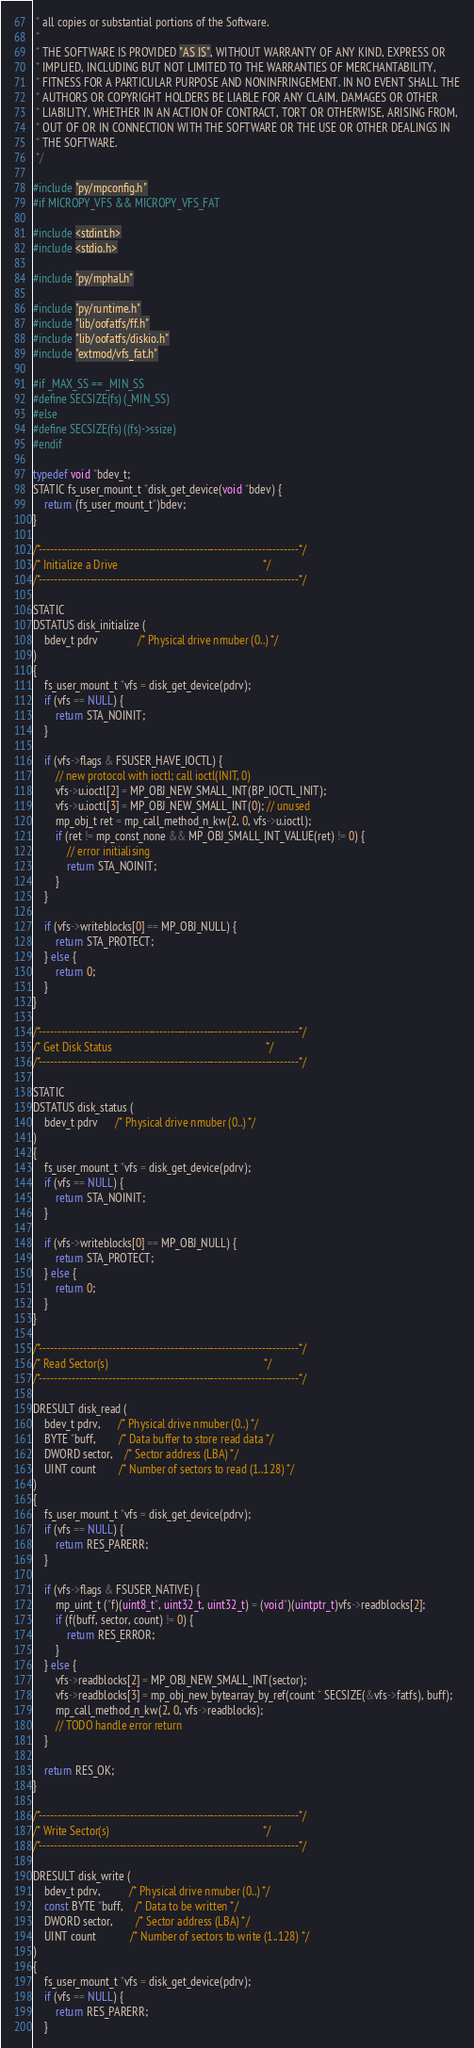Convert code to text. <code><loc_0><loc_0><loc_500><loc_500><_C_> * all copies or substantial portions of the Software.
 *
 * THE SOFTWARE IS PROVIDED "AS IS", WITHOUT WARRANTY OF ANY KIND, EXPRESS OR
 * IMPLIED, INCLUDING BUT NOT LIMITED TO THE WARRANTIES OF MERCHANTABILITY,
 * FITNESS FOR A PARTICULAR PURPOSE AND NONINFRINGEMENT. IN NO EVENT SHALL THE
 * AUTHORS OR COPYRIGHT HOLDERS BE LIABLE FOR ANY CLAIM, DAMAGES OR OTHER
 * LIABILITY, WHETHER IN AN ACTION OF CONTRACT, TORT OR OTHERWISE, ARISING FROM,
 * OUT OF OR IN CONNECTION WITH THE SOFTWARE OR THE USE OR OTHER DEALINGS IN
 * THE SOFTWARE.
 */

#include "py/mpconfig.h"
#if MICROPY_VFS && MICROPY_VFS_FAT

#include <stdint.h>
#include <stdio.h>

#include "py/mphal.h"

#include "py/runtime.h"
#include "lib/oofatfs/ff.h"
#include "lib/oofatfs/diskio.h"
#include "extmod/vfs_fat.h"

#if _MAX_SS == _MIN_SS
#define SECSIZE(fs) (_MIN_SS)
#else
#define SECSIZE(fs) ((fs)->ssize)
#endif

typedef void *bdev_t;
STATIC fs_user_mount_t *disk_get_device(void *bdev) {
    return (fs_user_mount_t*)bdev;
}

/*-----------------------------------------------------------------------*/
/* Initialize a Drive                                                    */
/*-----------------------------------------------------------------------*/

STATIC
DSTATUS disk_initialize (
    bdev_t pdrv              /* Physical drive nmuber (0..) */
)
{
    fs_user_mount_t *vfs = disk_get_device(pdrv);
    if (vfs == NULL) {
        return STA_NOINIT;
    }

    if (vfs->flags & FSUSER_HAVE_IOCTL) {
        // new protocol with ioctl; call ioctl(INIT, 0)
        vfs->u.ioctl[2] = MP_OBJ_NEW_SMALL_INT(BP_IOCTL_INIT);
        vfs->u.ioctl[3] = MP_OBJ_NEW_SMALL_INT(0); // unused
        mp_obj_t ret = mp_call_method_n_kw(2, 0, vfs->u.ioctl);
        if (ret != mp_const_none && MP_OBJ_SMALL_INT_VALUE(ret) != 0) {
            // error initialising
            return STA_NOINIT;
        }
    }

    if (vfs->writeblocks[0] == MP_OBJ_NULL) {
        return STA_PROTECT;
    } else {
        return 0;
    }
}

/*-----------------------------------------------------------------------*/
/* Get Disk Status                                                       */
/*-----------------------------------------------------------------------*/

STATIC
DSTATUS disk_status (
    bdev_t pdrv      /* Physical drive nmuber (0..) */
)
{
    fs_user_mount_t *vfs = disk_get_device(pdrv);
    if (vfs == NULL) {
        return STA_NOINIT;
    }

    if (vfs->writeblocks[0] == MP_OBJ_NULL) {
        return STA_PROTECT;
    } else {
        return 0;
    }
}

/*-----------------------------------------------------------------------*/
/* Read Sector(s)                                                        */
/*-----------------------------------------------------------------------*/

DRESULT disk_read (
    bdev_t pdrv,      /* Physical drive nmuber (0..) */
    BYTE *buff,        /* Data buffer to store read data */
    DWORD sector,    /* Sector address (LBA) */
    UINT count        /* Number of sectors to read (1..128) */
)
{
    fs_user_mount_t *vfs = disk_get_device(pdrv);
    if (vfs == NULL) {
        return RES_PARERR;
    }

    if (vfs->flags & FSUSER_NATIVE) {
        mp_uint_t (*f)(uint8_t*, uint32_t, uint32_t) = (void*)(uintptr_t)vfs->readblocks[2];
        if (f(buff, sector, count) != 0) {
            return RES_ERROR;
        }
    } else {
        vfs->readblocks[2] = MP_OBJ_NEW_SMALL_INT(sector);
        vfs->readblocks[3] = mp_obj_new_bytearray_by_ref(count * SECSIZE(&vfs->fatfs), buff);
        mp_call_method_n_kw(2, 0, vfs->readblocks);
        // TODO handle error return
    }

    return RES_OK;
}

/*-----------------------------------------------------------------------*/
/* Write Sector(s)                                                       */
/*-----------------------------------------------------------------------*/

DRESULT disk_write (
    bdev_t pdrv,          /* Physical drive nmuber (0..) */
    const BYTE *buff,    /* Data to be written */
    DWORD sector,        /* Sector address (LBA) */
    UINT count            /* Number of sectors to write (1..128) */
)
{
    fs_user_mount_t *vfs = disk_get_device(pdrv);
    if (vfs == NULL) {
        return RES_PARERR;
    }
</code> 